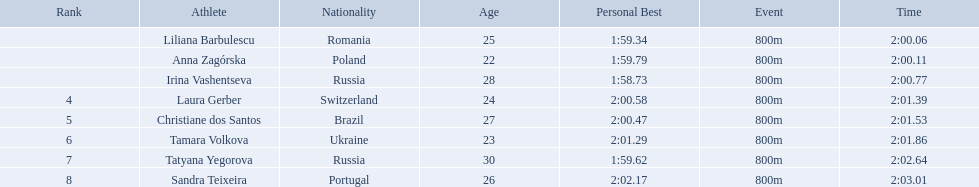What athletes are in the top five for the women's 800 metres? Liliana Barbulescu, Anna Zagórska, Irina Vashentseva, Laura Gerber, Christiane dos Santos. Which athletes are in the top 3? Liliana Barbulescu, Anna Zagórska, Irina Vashentseva. Who is the second place runner in the women's 800 metres? Anna Zagórska. What is the second place runner's time? 2:00.11. Who came in second place at the athletics at the 2003 summer universiade - women's 800 metres? Anna Zagórska. What was her time? 2:00.11. Who were the athlete were in the athletics at the 2003 summer universiade - women's 800 metres? , Liliana Barbulescu, Anna Zagórska, Irina Vashentseva, Laura Gerber, Christiane dos Santos, Tamara Volkova, Tatyana Yegorova, Sandra Teixeira. What was anna zagorska finishing time? 2:00.11. 